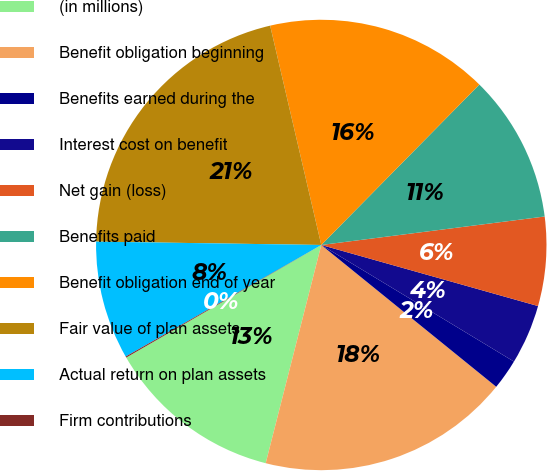Convert chart to OTSL. <chart><loc_0><loc_0><loc_500><loc_500><pie_chart><fcel>(in millions)<fcel>Benefit obligation beginning<fcel>Benefits earned during the<fcel>Interest cost on benefit<fcel>Net gain (loss)<fcel>Benefits paid<fcel>Benefit obligation end of year<fcel>Fair value of plan assets<fcel>Actual return on plan assets<fcel>Firm contributions<nl><fcel>12.7%<fcel>18.13%<fcel>2.18%<fcel>4.29%<fcel>6.39%<fcel>10.6%<fcel>16.03%<fcel>21.12%<fcel>8.49%<fcel>0.08%<nl></chart> 